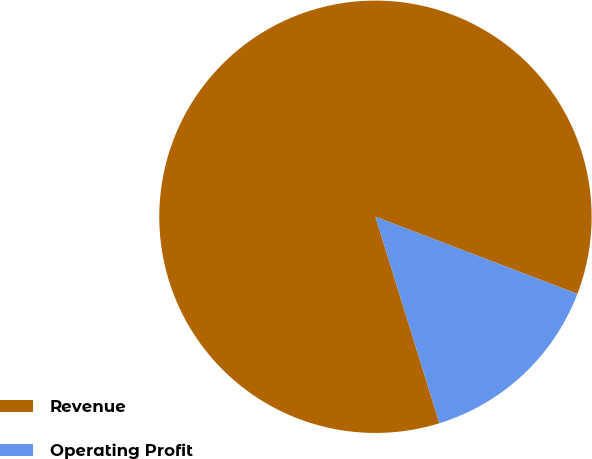<chart> <loc_0><loc_0><loc_500><loc_500><pie_chart><fcel>Revenue<fcel>Operating Profit<nl><fcel>85.59%<fcel>14.41%<nl></chart> 